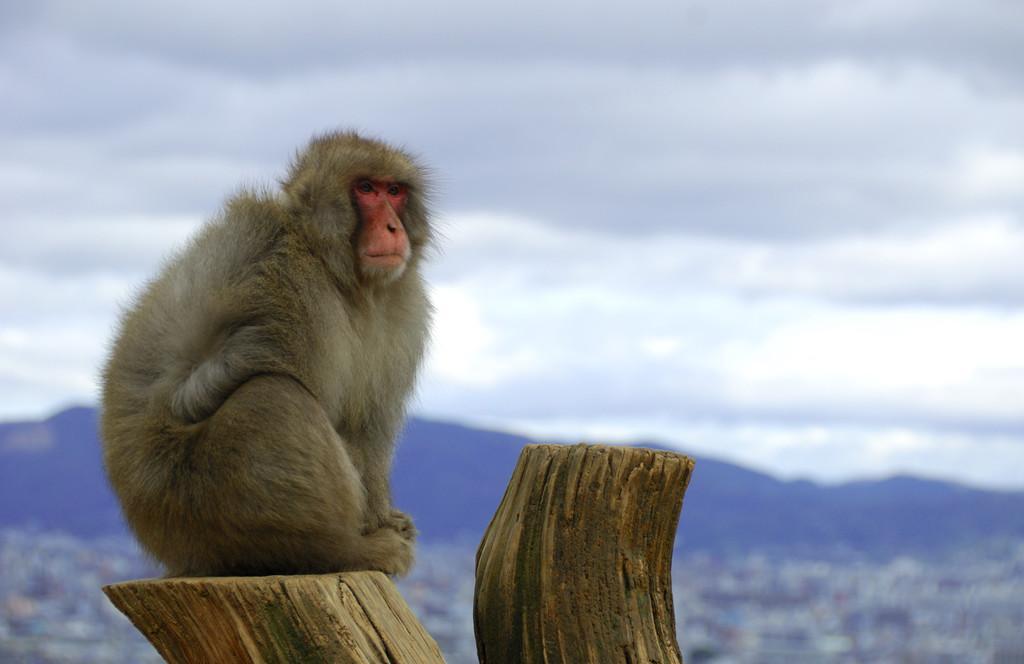Can you describe this image briefly? This image is taken outdoors. At the top of the image there is a sky with clouds. At the bottom of the image there is a bark and there is a monkey on the bark. In the background there is a hill. 